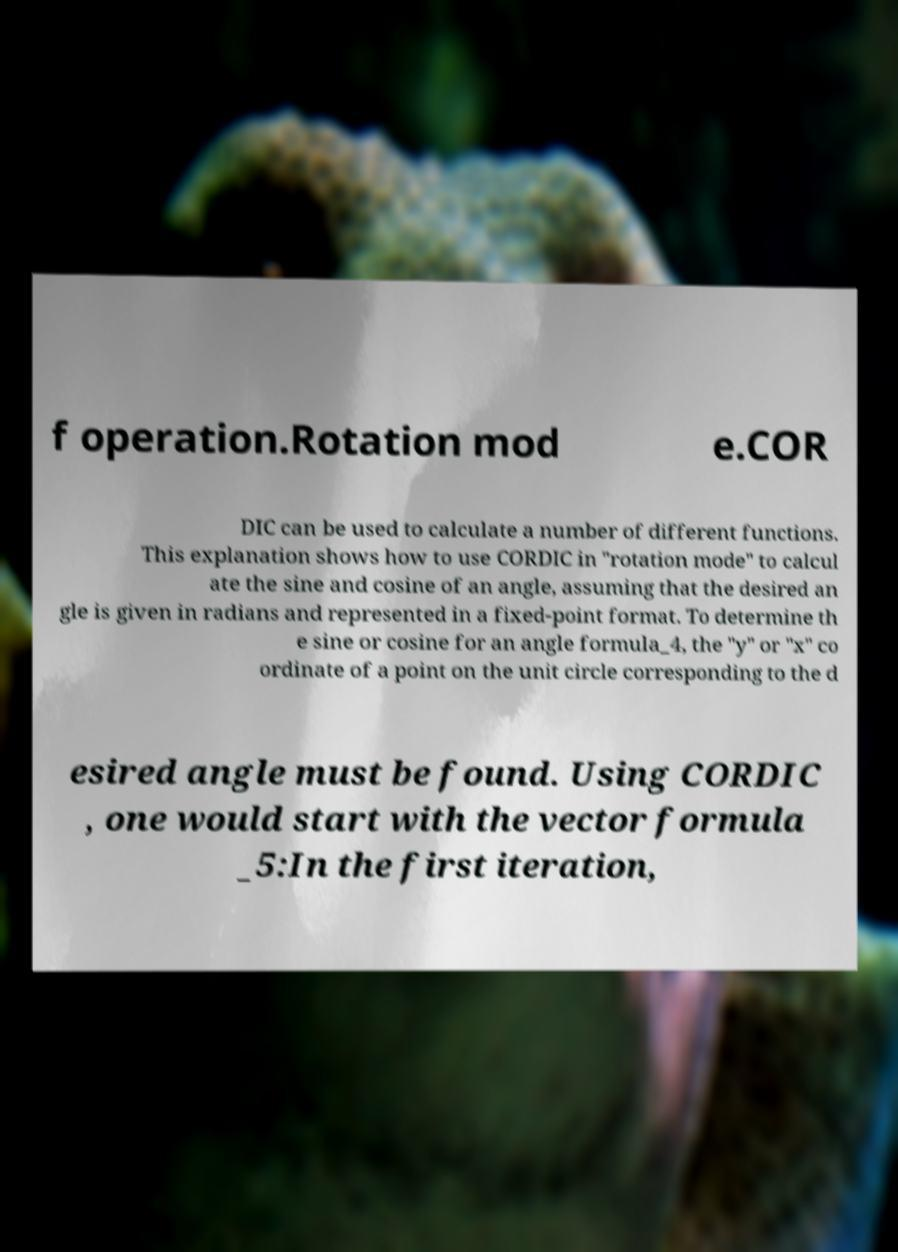Please identify and transcribe the text found in this image. f operation.Rotation mod e.COR DIC can be used to calculate a number of different functions. This explanation shows how to use CORDIC in "rotation mode" to calcul ate the sine and cosine of an angle, assuming that the desired an gle is given in radians and represented in a fixed-point format. To determine th e sine or cosine for an angle formula_4, the "y" or "x" co ordinate of a point on the unit circle corresponding to the d esired angle must be found. Using CORDIC , one would start with the vector formula _5:In the first iteration, 